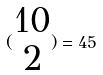Convert formula to latex. <formula><loc_0><loc_0><loc_500><loc_500>( \begin{matrix} 1 0 \\ 2 \end{matrix} ) = 4 5</formula> 